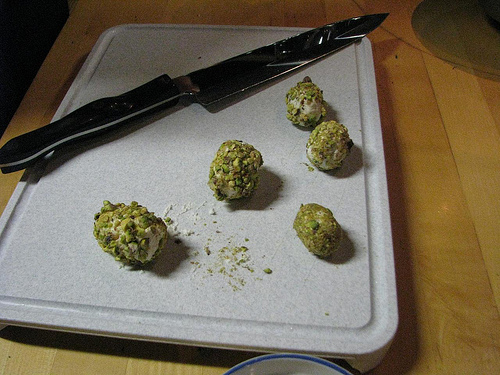<image>
Is there a knife above the table? Yes. The knife is positioned above the table in the vertical space, higher up in the scene. Is there a knife above the food? No. The knife is not positioned above the food. The vertical arrangement shows a different relationship. 